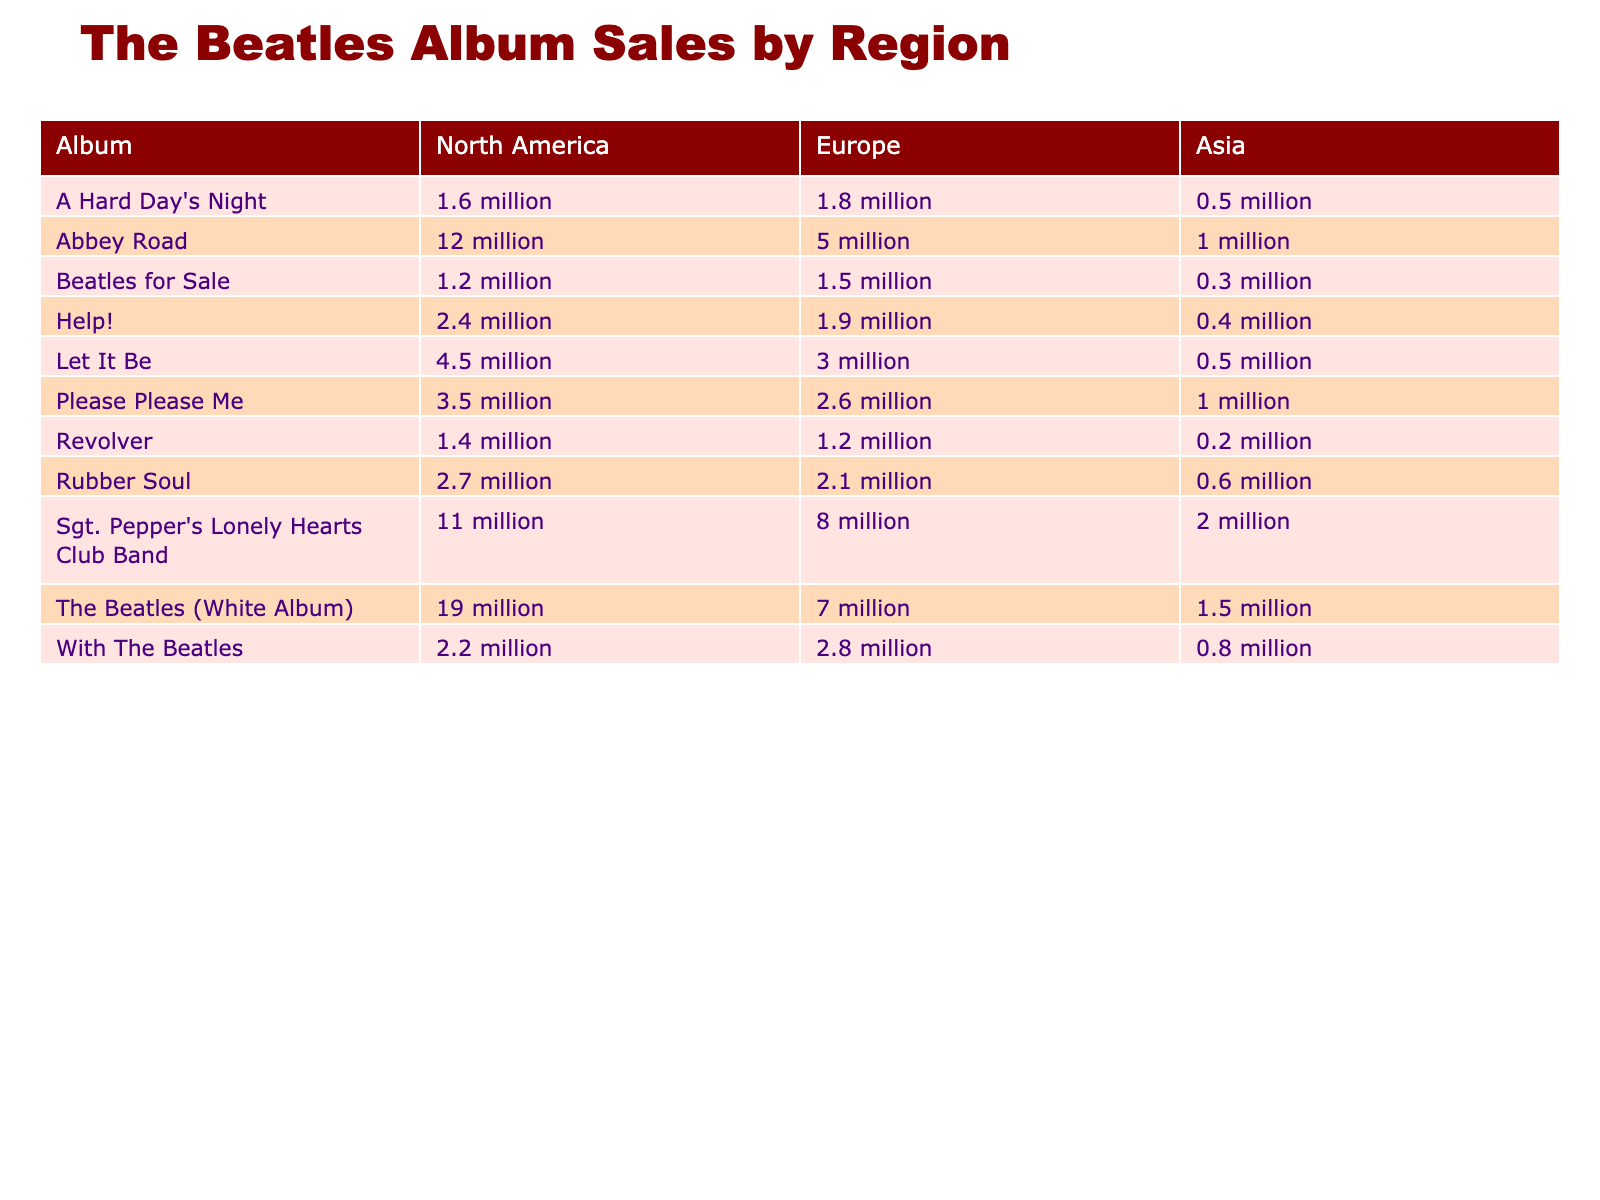What is the highest-selling album in North America? From the North America column, the album with the highest sales figure is "The Beatles (White Album)" with 19 million.
Answer: The Beatles (White Album) Which album had the lowest sales in Asia? The Asia column shows that "Revolver" has the lowest sales figure with 0.2 million.
Answer: Revolver What are the total sales figures for "Abbey Road"? Adding up the sales figures from all regions: North America (12 million) + Europe (5 million) + Asia (1 million) = 18 million.
Answer: 18 million Is "Help!" more popular in North America than in Europe? In North America, "Help!" sold 2.4 million, while in Europe it sold 1.9 million, which means it is indeed more popular in North America.
Answer: Yes What is the difference in sales figures for "Sgt. Pepper's Lonely Hearts Club Band" between North America and Asia? The North America sales are 11 million, and Asia sales are 2 million, so the difference is 11 million - 2 million = 9 million.
Answer: 9 million Which album had higher sales in North America compared to Europe and Asia combined? In North America, "Let It Be" sold 4.5 million, while in Europe it sold 3 million and in Asia it sold 0.5 million. Combined sales for Europe and Asia are 3 million + 0.5 million = 3.5 million, which is lower than North America's 4.5 million.
Answer: Yes What is the average sales figure for "Please Please Me" across all regions? The sales figures are 3.5 million (North America), 2.6 million (Europe), and 1 million (Asia). Adding these gives 3.5 + 2.6 + 1 = 7.1 million. Dividing by 3 (the number of regions) results in an average of about 2.37 million.
Answer: 2.37 million Which album had the most significant sales in Europe and how much was it? The "Sgt. Pepper's Lonely Hearts Club Band" had the most sales in Europe with 8 million.
Answer: Sgt. Pepper's Lonely Hearts Club Band, 8 million How do the total sales figures of "A Hard Day's Night" in North America and Europe compare? In North America it sold 1.6 million, and in Europe it sold 1.8 million. Comparing these shows that Europe (1.8 million) has higher sales than North America (1.6 million).
Answer: Europe has higher sales What percentage of the sales in North America does "Rubber Soul" represent compared to "The Beatles (White Album)"? "Rubber Soul" sold 2.7 million and "The Beatles (White Album)" sold 19 million. To find the percentage: (2.7 / 19) * 100 = approximately 14.21%.
Answer: 14.21% 